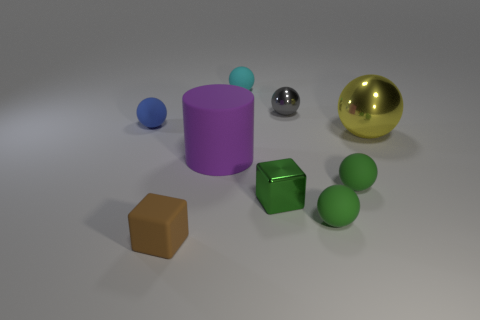What number of metallic objects are large yellow things or big cyan cylinders?
Offer a very short reply. 1. What number of small objects have the same color as the shiny cube?
Your answer should be very brief. 2. There is a cube that is on the right side of the large object left of the big ball; what is its material?
Give a very brief answer. Metal. The blue ball has what size?
Make the answer very short. Small. What number of green rubber spheres are the same size as the blue rubber ball?
Offer a very short reply. 2. What number of purple things are the same shape as the green metallic object?
Your answer should be very brief. 0. Is the number of tiny rubber objects that are on the right side of the tiny brown matte block the same as the number of large purple cylinders?
Provide a short and direct response. No. Is there any other thing that is the same size as the brown matte block?
Provide a short and direct response. Yes. The blue matte thing that is the same size as the gray shiny thing is what shape?
Your answer should be very brief. Sphere. Is there a red metallic object that has the same shape as the cyan object?
Your answer should be compact. No. 